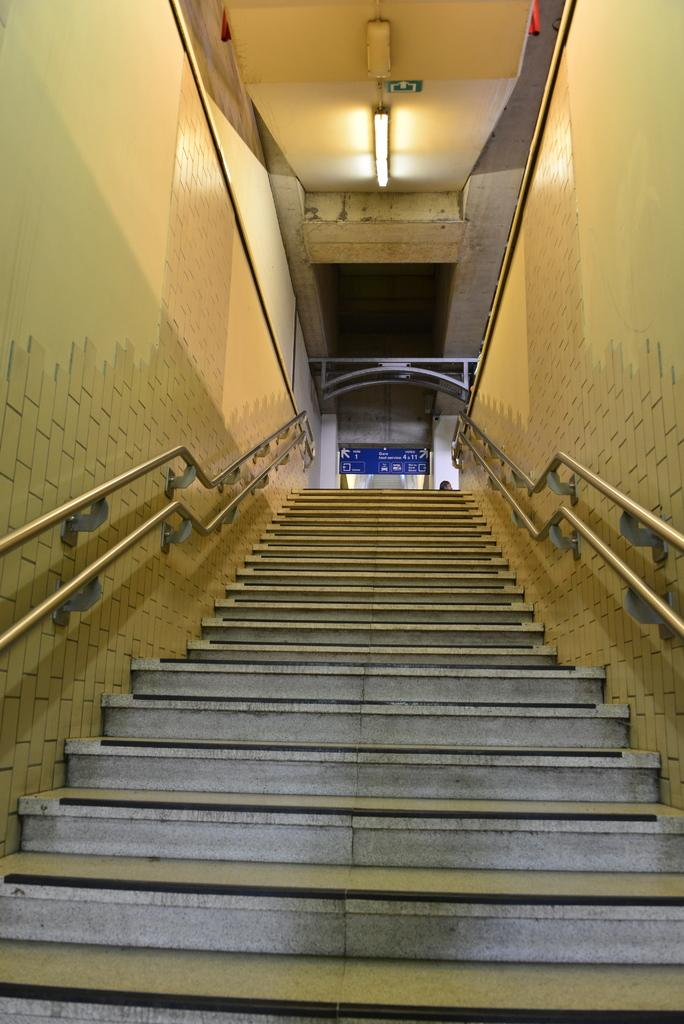What type of structure is present in the image? There are stairs in the image. What feature is present on the sides of the stairs? There are railings on the sides of the stairs. What else can be seen in the image besides the stairs and railings? There are walls visible in the image. What provides illumination in the background of the image? There is a light on the ceiling in the background. What type of stamp can be seen on the wall in the image? There is no stamp present on the wall in the image. Is there a fireman visible in the image? There is no fireman present in the image. 